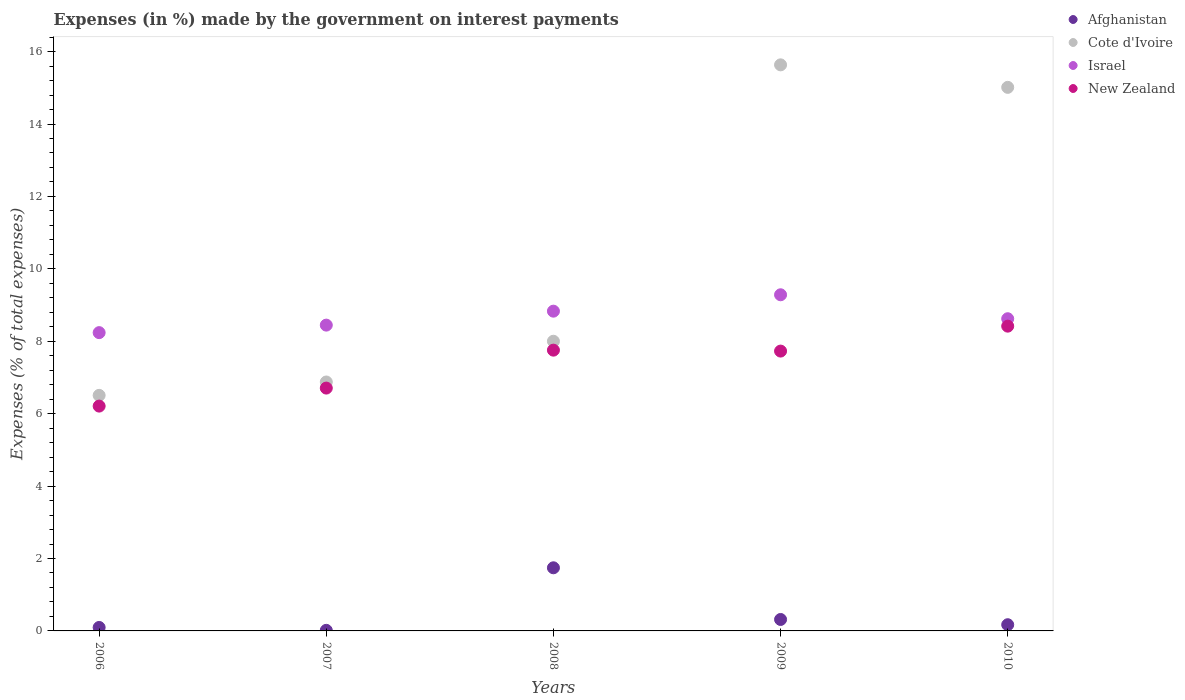What is the percentage of expenses made by the government on interest payments in New Zealand in 2010?
Keep it short and to the point. 8.42. Across all years, what is the maximum percentage of expenses made by the government on interest payments in New Zealand?
Your answer should be compact. 8.42. Across all years, what is the minimum percentage of expenses made by the government on interest payments in Cote d'Ivoire?
Make the answer very short. 6.51. In which year was the percentage of expenses made by the government on interest payments in Israel maximum?
Offer a terse response. 2009. What is the total percentage of expenses made by the government on interest payments in New Zealand in the graph?
Offer a very short reply. 36.82. What is the difference between the percentage of expenses made by the government on interest payments in Cote d'Ivoire in 2007 and that in 2008?
Ensure brevity in your answer.  -1.13. What is the difference between the percentage of expenses made by the government on interest payments in Afghanistan in 2007 and the percentage of expenses made by the government on interest payments in New Zealand in 2010?
Your response must be concise. -8.4. What is the average percentage of expenses made by the government on interest payments in Israel per year?
Make the answer very short. 8.68. In the year 2010, what is the difference between the percentage of expenses made by the government on interest payments in Afghanistan and percentage of expenses made by the government on interest payments in New Zealand?
Provide a short and direct response. -8.25. In how many years, is the percentage of expenses made by the government on interest payments in Israel greater than 14.8 %?
Your answer should be compact. 0. What is the ratio of the percentage of expenses made by the government on interest payments in Cote d'Ivoire in 2007 to that in 2008?
Your answer should be compact. 0.86. Is the difference between the percentage of expenses made by the government on interest payments in Afghanistan in 2008 and 2010 greater than the difference between the percentage of expenses made by the government on interest payments in New Zealand in 2008 and 2010?
Offer a terse response. Yes. What is the difference between the highest and the second highest percentage of expenses made by the government on interest payments in New Zealand?
Offer a very short reply. 0.66. What is the difference between the highest and the lowest percentage of expenses made by the government on interest payments in Afghanistan?
Your answer should be compact. 1.73. Is it the case that in every year, the sum of the percentage of expenses made by the government on interest payments in Cote d'Ivoire and percentage of expenses made by the government on interest payments in New Zealand  is greater than the percentage of expenses made by the government on interest payments in Afghanistan?
Offer a terse response. Yes. How many dotlines are there?
Provide a short and direct response. 4. What is the difference between two consecutive major ticks on the Y-axis?
Provide a short and direct response. 2. Where does the legend appear in the graph?
Your response must be concise. Top right. How many legend labels are there?
Ensure brevity in your answer.  4. How are the legend labels stacked?
Your answer should be compact. Vertical. What is the title of the graph?
Your answer should be compact. Expenses (in %) made by the government on interest payments. Does "Vietnam" appear as one of the legend labels in the graph?
Offer a very short reply. No. What is the label or title of the Y-axis?
Your answer should be very brief. Expenses (% of total expenses). What is the Expenses (% of total expenses) of Afghanistan in 2006?
Provide a short and direct response. 0.1. What is the Expenses (% of total expenses) in Cote d'Ivoire in 2006?
Offer a very short reply. 6.51. What is the Expenses (% of total expenses) of Israel in 2006?
Offer a terse response. 8.24. What is the Expenses (% of total expenses) of New Zealand in 2006?
Offer a terse response. 6.21. What is the Expenses (% of total expenses) in Afghanistan in 2007?
Keep it short and to the point. 0.02. What is the Expenses (% of total expenses) in Cote d'Ivoire in 2007?
Your response must be concise. 6.88. What is the Expenses (% of total expenses) of Israel in 2007?
Your answer should be very brief. 8.45. What is the Expenses (% of total expenses) of New Zealand in 2007?
Offer a terse response. 6.71. What is the Expenses (% of total expenses) of Afghanistan in 2008?
Offer a very short reply. 1.74. What is the Expenses (% of total expenses) of Cote d'Ivoire in 2008?
Make the answer very short. 8. What is the Expenses (% of total expenses) in Israel in 2008?
Your answer should be compact. 8.83. What is the Expenses (% of total expenses) in New Zealand in 2008?
Offer a very short reply. 7.75. What is the Expenses (% of total expenses) in Afghanistan in 2009?
Provide a short and direct response. 0.32. What is the Expenses (% of total expenses) of Cote d'Ivoire in 2009?
Offer a terse response. 15.63. What is the Expenses (% of total expenses) in Israel in 2009?
Make the answer very short. 9.28. What is the Expenses (% of total expenses) in New Zealand in 2009?
Give a very brief answer. 7.73. What is the Expenses (% of total expenses) of Afghanistan in 2010?
Your answer should be very brief. 0.17. What is the Expenses (% of total expenses) of Cote d'Ivoire in 2010?
Offer a very short reply. 15.01. What is the Expenses (% of total expenses) of Israel in 2010?
Provide a short and direct response. 8.62. What is the Expenses (% of total expenses) of New Zealand in 2010?
Your answer should be compact. 8.42. Across all years, what is the maximum Expenses (% of total expenses) of Afghanistan?
Your answer should be very brief. 1.74. Across all years, what is the maximum Expenses (% of total expenses) of Cote d'Ivoire?
Your response must be concise. 15.63. Across all years, what is the maximum Expenses (% of total expenses) of Israel?
Offer a terse response. 9.28. Across all years, what is the maximum Expenses (% of total expenses) in New Zealand?
Offer a terse response. 8.42. Across all years, what is the minimum Expenses (% of total expenses) of Afghanistan?
Keep it short and to the point. 0.02. Across all years, what is the minimum Expenses (% of total expenses) in Cote d'Ivoire?
Your answer should be compact. 6.51. Across all years, what is the minimum Expenses (% of total expenses) in Israel?
Give a very brief answer. 8.24. Across all years, what is the minimum Expenses (% of total expenses) of New Zealand?
Your answer should be very brief. 6.21. What is the total Expenses (% of total expenses) in Afghanistan in the graph?
Make the answer very short. 2.34. What is the total Expenses (% of total expenses) in Cote d'Ivoire in the graph?
Give a very brief answer. 52.03. What is the total Expenses (% of total expenses) in Israel in the graph?
Keep it short and to the point. 43.42. What is the total Expenses (% of total expenses) in New Zealand in the graph?
Your answer should be compact. 36.82. What is the difference between the Expenses (% of total expenses) in Afghanistan in 2006 and that in 2007?
Give a very brief answer. 0.08. What is the difference between the Expenses (% of total expenses) of Cote d'Ivoire in 2006 and that in 2007?
Offer a very short reply. -0.37. What is the difference between the Expenses (% of total expenses) of Israel in 2006 and that in 2007?
Your response must be concise. -0.21. What is the difference between the Expenses (% of total expenses) of New Zealand in 2006 and that in 2007?
Provide a short and direct response. -0.5. What is the difference between the Expenses (% of total expenses) of Afghanistan in 2006 and that in 2008?
Your answer should be very brief. -1.65. What is the difference between the Expenses (% of total expenses) in Cote d'Ivoire in 2006 and that in 2008?
Provide a short and direct response. -1.49. What is the difference between the Expenses (% of total expenses) of Israel in 2006 and that in 2008?
Your answer should be compact. -0.59. What is the difference between the Expenses (% of total expenses) in New Zealand in 2006 and that in 2008?
Provide a short and direct response. -1.55. What is the difference between the Expenses (% of total expenses) of Afghanistan in 2006 and that in 2009?
Offer a terse response. -0.22. What is the difference between the Expenses (% of total expenses) of Cote d'Ivoire in 2006 and that in 2009?
Your answer should be compact. -9.13. What is the difference between the Expenses (% of total expenses) of Israel in 2006 and that in 2009?
Your answer should be compact. -1.05. What is the difference between the Expenses (% of total expenses) of New Zealand in 2006 and that in 2009?
Offer a terse response. -1.52. What is the difference between the Expenses (% of total expenses) in Afghanistan in 2006 and that in 2010?
Ensure brevity in your answer.  -0.08. What is the difference between the Expenses (% of total expenses) in Cote d'Ivoire in 2006 and that in 2010?
Provide a short and direct response. -8.51. What is the difference between the Expenses (% of total expenses) of Israel in 2006 and that in 2010?
Your answer should be very brief. -0.38. What is the difference between the Expenses (% of total expenses) in New Zealand in 2006 and that in 2010?
Make the answer very short. -2.21. What is the difference between the Expenses (% of total expenses) in Afghanistan in 2007 and that in 2008?
Offer a terse response. -1.73. What is the difference between the Expenses (% of total expenses) of Cote d'Ivoire in 2007 and that in 2008?
Ensure brevity in your answer.  -1.13. What is the difference between the Expenses (% of total expenses) in Israel in 2007 and that in 2008?
Provide a short and direct response. -0.39. What is the difference between the Expenses (% of total expenses) in New Zealand in 2007 and that in 2008?
Offer a very short reply. -1.05. What is the difference between the Expenses (% of total expenses) of Afghanistan in 2007 and that in 2009?
Make the answer very short. -0.3. What is the difference between the Expenses (% of total expenses) in Cote d'Ivoire in 2007 and that in 2009?
Offer a terse response. -8.76. What is the difference between the Expenses (% of total expenses) of Israel in 2007 and that in 2009?
Make the answer very short. -0.84. What is the difference between the Expenses (% of total expenses) in New Zealand in 2007 and that in 2009?
Your answer should be very brief. -1.02. What is the difference between the Expenses (% of total expenses) of Afghanistan in 2007 and that in 2010?
Make the answer very short. -0.16. What is the difference between the Expenses (% of total expenses) in Cote d'Ivoire in 2007 and that in 2010?
Ensure brevity in your answer.  -8.14. What is the difference between the Expenses (% of total expenses) in Israel in 2007 and that in 2010?
Your answer should be compact. -0.18. What is the difference between the Expenses (% of total expenses) in New Zealand in 2007 and that in 2010?
Provide a succinct answer. -1.71. What is the difference between the Expenses (% of total expenses) of Afghanistan in 2008 and that in 2009?
Your answer should be compact. 1.43. What is the difference between the Expenses (% of total expenses) in Cote d'Ivoire in 2008 and that in 2009?
Offer a terse response. -7.63. What is the difference between the Expenses (% of total expenses) of Israel in 2008 and that in 2009?
Keep it short and to the point. -0.45. What is the difference between the Expenses (% of total expenses) of New Zealand in 2008 and that in 2009?
Offer a terse response. 0.03. What is the difference between the Expenses (% of total expenses) in Afghanistan in 2008 and that in 2010?
Provide a short and direct response. 1.57. What is the difference between the Expenses (% of total expenses) of Cote d'Ivoire in 2008 and that in 2010?
Offer a terse response. -7.01. What is the difference between the Expenses (% of total expenses) in Israel in 2008 and that in 2010?
Provide a short and direct response. 0.21. What is the difference between the Expenses (% of total expenses) in New Zealand in 2008 and that in 2010?
Your answer should be compact. -0.66. What is the difference between the Expenses (% of total expenses) of Afghanistan in 2009 and that in 2010?
Provide a short and direct response. 0.14. What is the difference between the Expenses (% of total expenses) in Cote d'Ivoire in 2009 and that in 2010?
Your answer should be very brief. 0.62. What is the difference between the Expenses (% of total expenses) of Israel in 2009 and that in 2010?
Provide a short and direct response. 0.66. What is the difference between the Expenses (% of total expenses) of New Zealand in 2009 and that in 2010?
Offer a very short reply. -0.69. What is the difference between the Expenses (% of total expenses) in Afghanistan in 2006 and the Expenses (% of total expenses) in Cote d'Ivoire in 2007?
Offer a very short reply. -6.78. What is the difference between the Expenses (% of total expenses) in Afghanistan in 2006 and the Expenses (% of total expenses) in Israel in 2007?
Make the answer very short. -8.35. What is the difference between the Expenses (% of total expenses) in Afghanistan in 2006 and the Expenses (% of total expenses) in New Zealand in 2007?
Provide a succinct answer. -6.61. What is the difference between the Expenses (% of total expenses) in Cote d'Ivoire in 2006 and the Expenses (% of total expenses) in Israel in 2007?
Offer a very short reply. -1.94. What is the difference between the Expenses (% of total expenses) of Cote d'Ivoire in 2006 and the Expenses (% of total expenses) of New Zealand in 2007?
Provide a succinct answer. -0.2. What is the difference between the Expenses (% of total expenses) of Israel in 2006 and the Expenses (% of total expenses) of New Zealand in 2007?
Offer a terse response. 1.53. What is the difference between the Expenses (% of total expenses) in Afghanistan in 2006 and the Expenses (% of total expenses) in Cote d'Ivoire in 2008?
Your response must be concise. -7.9. What is the difference between the Expenses (% of total expenses) in Afghanistan in 2006 and the Expenses (% of total expenses) in Israel in 2008?
Your response must be concise. -8.74. What is the difference between the Expenses (% of total expenses) in Afghanistan in 2006 and the Expenses (% of total expenses) in New Zealand in 2008?
Ensure brevity in your answer.  -7.66. What is the difference between the Expenses (% of total expenses) of Cote d'Ivoire in 2006 and the Expenses (% of total expenses) of Israel in 2008?
Your response must be concise. -2.33. What is the difference between the Expenses (% of total expenses) in Cote d'Ivoire in 2006 and the Expenses (% of total expenses) in New Zealand in 2008?
Give a very brief answer. -1.25. What is the difference between the Expenses (% of total expenses) of Israel in 2006 and the Expenses (% of total expenses) of New Zealand in 2008?
Provide a succinct answer. 0.48. What is the difference between the Expenses (% of total expenses) of Afghanistan in 2006 and the Expenses (% of total expenses) of Cote d'Ivoire in 2009?
Provide a succinct answer. -15.54. What is the difference between the Expenses (% of total expenses) of Afghanistan in 2006 and the Expenses (% of total expenses) of Israel in 2009?
Your response must be concise. -9.19. What is the difference between the Expenses (% of total expenses) of Afghanistan in 2006 and the Expenses (% of total expenses) of New Zealand in 2009?
Provide a succinct answer. -7.63. What is the difference between the Expenses (% of total expenses) of Cote d'Ivoire in 2006 and the Expenses (% of total expenses) of Israel in 2009?
Provide a succinct answer. -2.78. What is the difference between the Expenses (% of total expenses) of Cote d'Ivoire in 2006 and the Expenses (% of total expenses) of New Zealand in 2009?
Provide a short and direct response. -1.22. What is the difference between the Expenses (% of total expenses) in Israel in 2006 and the Expenses (% of total expenses) in New Zealand in 2009?
Offer a very short reply. 0.51. What is the difference between the Expenses (% of total expenses) of Afghanistan in 2006 and the Expenses (% of total expenses) of Cote d'Ivoire in 2010?
Offer a very short reply. -14.92. What is the difference between the Expenses (% of total expenses) of Afghanistan in 2006 and the Expenses (% of total expenses) of Israel in 2010?
Make the answer very short. -8.53. What is the difference between the Expenses (% of total expenses) in Afghanistan in 2006 and the Expenses (% of total expenses) in New Zealand in 2010?
Make the answer very short. -8.32. What is the difference between the Expenses (% of total expenses) of Cote d'Ivoire in 2006 and the Expenses (% of total expenses) of Israel in 2010?
Ensure brevity in your answer.  -2.12. What is the difference between the Expenses (% of total expenses) in Cote d'Ivoire in 2006 and the Expenses (% of total expenses) in New Zealand in 2010?
Make the answer very short. -1.91. What is the difference between the Expenses (% of total expenses) of Israel in 2006 and the Expenses (% of total expenses) of New Zealand in 2010?
Your response must be concise. -0.18. What is the difference between the Expenses (% of total expenses) in Afghanistan in 2007 and the Expenses (% of total expenses) in Cote d'Ivoire in 2008?
Your answer should be very brief. -7.98. What is the difference between the Expenses (% of total expenses) of Afghanistan in 2007 and the Expenses (% of total expenses) of Israel in 2008?
Provide a succinct answer. -8.82. What is the difference between the Expenses (% of total expenses) in Afghanistan in 2007 and the Expenses (% of total expenses) in New Zealand in 2008?
Provide a succinct answer. -7.74. What is the difference between the Expenses (% of total expenses) of Cote d'Ivoire in 2007 and the Expenses (% of total expenses) of Israel in 2008?
Provide a short and direct response. -1.96. What is the difference between the Expenses (% of total expenses) of Cote d'Ivoire in 2007 and the Expenses (% of total expenses) of New Zealand in 2008?
Provide a succinct answer. -0.88. What is the difference between the Expenses (% of total expenses) of Israel in 2007 and the Expenses (% of total expenses) of New Zealand in 2008?
Provide a short and direct response. 0.69. What is the difference between the Expenses (% of total expenses) in Afghanistan in 2007 and the Expenses (% of total expenses) in Cote d'Ivoire in 2009?
Offer a terse response. -15.62. What is the difference between the Expenses (% of total expenses) of Afghanistan in 2007 and the Expenses (% of total expenses) of Israel in 2009?
Keep it short and to the point. -9.27. What is the difference between the Expenses (% of total expenses) in Afghanistan in 2007 and the Expenses (% of total expenses) in New Zealand in 2009?
Ensure brevity in your answer.  -7.71. What is the difference between the Expenses (% of total expenses) of Cote d'Ivoire in 2007 and the Expenses (% of total expenses) of Israel in 2009?
Offer a very short reply. -2.41. What is the difference between the Expenses (% of total expenses) in Cote d'Ivoire in 2007 and the Expenses (% of total expenses) in New Zealand in 2009?
Offer a very short reply. -0.85. What is the difference between the Expenses (% of total expenses) in Israel in 2007 and the Expenses (% of total expenses) in New Zealand in 2009?
Your response must be concise. 0.72. What is the difference between the Expenses (% of total expenses) in Afghanistan in 2007 and the Expenses (% of total expenses) in Cote d'Ivoire in 2010?
Keep it short and to the point. -15. What is the difference between the Expenses (% of total expenses) in Afghanistan in 2007 and the Expenses (% of total expenses) in Israel in 2010?
Your answer should be very brief. -8.61. What is the difference between the Expenses (% of total expenses) of Afghanistan in 2007 and the Expenses (% of total expenses) of New Zealand in 2010?
Your response must be concise. -8.4. What is the difference between the Expenses (% of total expenses) in Cote d'Ivoire in 2007 and the Expenses (% of total expenses) in Israel in 2010?
Your answer should be very brief. -1.75. What is the difference between the Expenses (% of total expenses) in Cote d'Ivoire in 2007 and the Expenses (% of total expenses) in New Zealand in 2010?
Your answer should be very brief. -1.54. What is the difference between the Expenses (% of total expenses) of Israel in 2007 and the Expenses (% of total expenses) of New Zealand in 2010?
Make the answer very short. 0.03. What is the difference between the Expenses (% of total expenses) in Afghanistan in 2008 and the Expenses (% of total expenses) in Cote d'Ivoire in 2009?
Ensure brevity in your answer.  -13.89. What is the difference between the Expenses (% of total expenses) in Afghanistan in 2008 and the Expenses (% of total expenses) in Israel in 2009?
Your answer should be very brief. -7.54. What is the difference between the Expenses (% of total expenses) in Afghanistan in 2008 and the Expenses (% of total expenses) in New Zealand in 2009?
Make the answer very short. -5.99. What is the difference between the Expenses (% of total expenses) in Cote d'Ivoire in 2008 and the Expenses (% of total expenses) in Israel in 2009?
Your answer should be compact. -1.28. What is the difference between the Expenses (% of total expenses) of Cote d'Ivoire in 2008 and the Expenses (% of total expenses) of New Zealand in 2009?
Keep it short and to the point. 0.27. What is the difference between the Expenses (% of total expenses) in Israel in 2008 and the Expenses (% of total expenses) in New Zealand in 2009?
Make the answer very short. 1.1. What is the difference between the Expenses (% of total expenses) of Afghanistan in 2008 and the Expenses (% of total expenses) of Cote d'Ivoire in 2010?
Your response must be concise. -13.27. What is the difference between the Expenses (% of total expenses) in Afghanistan in 2008 and the Expenses (% of total expenses) in Israel in 2010?
Offer a terse response. -6.88. What is the difference between the Expenses (% of total expenses) of Afghanistan in 2008 and the Expenses (% of total expenses) of New Zealand in 2010?
Offer a very short reply. -6.67. What is the difference between the Expenses (% of total expenses) in Cote d'Ivoire in 2008 and the Expenses (% of total expenses) in Israel in 2010?
Keep it short and to the point. -0.62. What is the difference between the Expenses (% of total expenses) of Cote d'Ivoire in 2008 and the Expenses (% of total expenses) of New Zealand in 2010?
Offer a terse response. -0.42. What is the difference between the Expenses (% of total expenses) of Israel in 2008 and the Expenses (% of total expenses) of New Zealand in 2010?
Give a very brief answer. 0.41. What is the difference between the Expenses (% of total expenses) in Afghanistan in 2009 and the Expenses (% of total expenses) in Cote d'Ivoire in 2010?
Ensure brevity in your answer.  -14.7. What is the difference between the Expenses (% of total expenses) of Afghanistan in 2009 and the Expenses (% of total expenses) of Israel in 2010?
Provide a short and direct response. -8.31. What is the difference between the Expenses (% of total expenses) of Afghanistan in 2009 and the Expenses (% of total expenses) of New Zealand in 2010?
Your answer should be very brief. -8.1. What is the difference between the Expenses (% of total expenses) of Cote d'Ivoire in 2009 and the Expenses (% of total expenses) of Israel in 2010?
Offer a very short reply. 7.01. What is the difference between the Expenses (% of total expenses) of Cote d'Ivoire in 2009 and the Expenses (% of total expenses) of New Zealand in 2010?
Keep it short and to the point. 7.22. What is the difference between the Expenses (% of total expenses) in Israel in 2009 and the Expenses (% of total expenses) in New Zealand in 2010?
Your answer should be very brief. 0.87. What is the average Expenses (% of total expenses) in Afghanistan per year?
Offer a very short reply. 0.47. What is the average Expenses (% of total expenses) of Cote d'Ivoire per year?
Offer a terse response. 10.41. What is the average Expenses (% of total expenses) in Israel per year?
Provide a succinct answer. 8.68. What is the average Expenses (% of total expenses) of New Zealand per year?
Provide a succinct answer. 7.36. In the year 2006, what is the difference between the Expenses (% of total expenses) of Afghanistan and Expenses (% of total expenses) of Cote d'Ivoire?
Offer a terse response. -6.41. In the year 2006, what is the difference between the Expenses (% of total expenses) in Afghanistan and Expenses (% of total expenses) in Israel?
Provide a short and direct response. -8.14. In the year 2006, what is the difference between the Expenses (% of total expenses) of Afghanistan and Expenses (% of total expenses) of New Zealand?
Provide a short and direct response. -6.11. In the year 2006, what is the difference between the Expenses (% of total expenses) of Cote d'Ivoire and Expenses (% of total expenses) of Israel?
Keep it short and to the point. -1.73. In the year 2006, what is the difference between the Expenses (% of total expenses) in Cote d'Ivoire and Expenses (% of total expenses) in New Zealand?
Make the answer very short. 0.3. In the year 2006, what is the difference between the Expenses (% of total expenses) in Israel and Expenses (% of total expenses) in New Zealand?
Your answer should be compact. 2.03. In the year 2007, what is the difference between the Expenses (% of total expenses) of Afghanistan and Expenses (% of total expenses) of Cote d'Ivoire?
Your answer should be compact. -6.86. In the year 2007, what is the difference between the Expenses (% of total expenses) in Afghanistan and Expenses (% of total expenses) in Israel?
Give a very brief answer. -8.43. In the year 2007, what is the difference between the Expenses (% of total expenses) in Afghanistan and Expenses (% of total expenses) in New Zealand?
Provide a succinct answer. -6.69. In the year 2007, what is the difference between the Expenses (% of total expenses) in Cote d'Ivoire and Expenses (% of total expenses) in Israel?
Give a very brief answer. -1.57. In the year 2007, what is the difference between the Expenses (% of total expenses) in Cote d'Ivoire and Expenses (% of total expenses) in New Zealand?
Provide a short and direct response. 0.17. In the year 2007, what is the difference between the Expenses (% of total expenses) of Israel and Expenses (% of total expenses) of New Zealand?
Offer a very short reply. 1.74. In the year 2008, what is the difference between the Expenses (% of total expenses) of Afghanistan and Expenses (% of total expenses) of Cote d'Ivoire?
Give a very brief answer. -6.26. In the year 2008, what is the difference between the Expenses (% of total expenses) of Afghanistan and Expenses (% of total expenses) of Israel?
Provide a succinct answer. -7.09. In the year 2008, what is the difference between the Expenses (% of total expenses) of Afghanistan and Expenses (% of total expenses) of New Zealand?
Keep it short and to the point. -6.01. In the year 2008, what is the difference between the Expenses (% of total expenses) of Cote d'Ivoire and Expenses (% of total expenses) of Israel?
Your answer should be very brief. -0.83. In the year 2008, what is the difference between the Expenses (% of total expenses) of Cote d'Ivoire and Expenses (% of total expenses) of New Zealand?
Ensure brevity in your answer.  0.25. In the year 2008, what is the difference between the Expenses (% of total expenses) in Israel and Expenses (% of total expenses) in New Zealand?
Offer a very short reply. 1.08. In the year 2009, what is the difference between the Expenses (% of total expenses) of Afghanistan and Expenses (% of total expenses) of Cote d'Ivoire?
Your response must be concise. -15.32. In the year 2009, what is the difference between the Expenses (% of total expenses) in Afghanistan and Expenses (% of total expenses) in Israel?
Provide a short and direct response. -8.97. In the year 2009, what is the difference between the Expenses (% of total expenses) in Afghanistan and Expenses (% of total expenses) in New Zealand?
Your answer should be very brief. -7.41. In the year 2009, what is the difference between the Expenses (% of total expenses) of Cote d'Ivoire and Expenses (% of total expenses) of Israel?
Offer a terse response. 6.35. In the year 2009, what is the difference between the Expenses (% of total expenses) in Cote d'Ivoire and Expenses (% of total expenses) in New Zealand?
Offer a very short reply. 7.91. In the year 2009, what is the difference between the Expenses (% of total expenses) of Israel and Expenses (% of total expenses) of New Zealand?
Give a very brief answer. 1.56. In the year 2010, what is the difference between the Expenses (% of total expenses) of Afghanistan and Expenses (% of total expenses) of Cote d'Ivoire?
Provide a short and direct response. -14.84. In the year 2010, what is the difference between the Expenses (% of total expenses) in Afghanistan and Expenses (% of total expenses) in Israel?
Give a very brief answer. -8.45. In the year 2010, what is the difference between the Expenses (% of total expenses) in Afghanistan and Expenses (% of total expenses) in New Zealand?
Offer a terse response. -8.25. In the year 2010, what is the difference between the Expenses (% of total expenses) of Cote d'Ivoire and Expenses (% of total expenses) of Israel?
Give a very brief answer. 6.39. In the year 2010, what is the difference between the Expenses (% of total expenses) of Cote d'Ivoire and Expenses (% of total expenses) of New Zealand?
Give a very brief answer. 6.6. In the year 2010, what is the difference between the Expenses (% of total expenses) of Israel and Expenses (% of total expenses) of New Zealand?
Keep it short and to the point. 0.21. What is the ratio of the Expenses (% of total expenses) of Afghanistan in 2006 to that in 2007?
Keep it short and to the point. 5.95. What is the ratio of the Expenses (% of total expenses) of Cote d'Ivoire in 2006 to that in 2007?
Provide a succinct answer. 0.95. What is the ratio of the Expenses (% of total expenses) of Israel in 2006 to that in 2007?
Ensure brevity in your answer.  0.98. What is the ratio of the Expenses (% of total expenses) in New Zealand in 2006 to that in 2007?
Provide a succinct answer. 0.93. What is the ratio of the Expenses (% of total expenses) of Afghanistan in 2006 to that in 2008?
Offer a terse response. 0.05. What is the ratio of the Expenses (% of total expenses) of Cote d'Ivoire in 2006 to that in 2008?
Make the answer very short. 0.81. What is the ratio of the Expenses (% of total expenses) in Israel in 2006 to that in 2008?
Keep it short and to the point. 0.93. What is the ratio of the Expenses (% of total expenses) in New Zealand in 2006 to that in 2008?
Give a very brief answer. 0.8. What is the ratio of the Expenses (% of total expenses) of Afghanistan in 2006 to that in 2009?
Offer a very short reply. 0.3. What is the ratio of the Expenses (% of total expenses) of Cote d'Ivoire in 2006 to that in 2009?
Give a very brief answer. 0.42. What is the ratio of the Expenses (% of total expenses) in Israel in 2006 to that in 2009?
Your response must be concise. 0.89. What is the ratio of the Expenses (% of total expenses) in New Zealand in 2006 to that in 2009?
Provide a short and direct response. 0.8. What is the ratio of the Expenses (% of total expenses) of Afghanistan in 2006 to that in 2010?
Give a very brief answer. 0.56. What is the ratio of the Expenses (% of total expenses) in Cote d'Ivoire in 2006 to that in 2010?
Your answer should be very brief. 0.43. What is the ratio of the Expenses (% of total expenses) in Israel in 2006 to that in 2010?
Provide a short and direct response. 0.96. What is the ratio of the Expenses (% of total expenses) in New Zealand in 2006 to that in 2010?
Make the answer very short. 0.74. What is the ratio of the Expenses (% of total expenses) in Afghanistan in 2007 to that in 2008?
Give a very brief answer. 0.01. What is the ratio of the Expenses (% of total expenses) of Cote d'Ivoire in 2007 to that in 2008?
Your answer should be compact. 0.86. What is the ratio of the Expenses (% of total expenses) of Israel in 2007 to that in 2008?
Offer a terse response. 0.96. What is the ratio of the Expenses (% of total expenses) in New Zealand in 2007 to that in 2008?
Your answer should be very brief. 0.86. What is the ratio of the Expenses (% of total expenses) in Afghanistan in 2007 to that in 2009?
Offer a very short reply. 0.05. What is the ratio of the Expenses (% of total expenses) of Cote d'Ivoire in 2007 to that in 2009?
Your response must be concise. 0.44. What is the ratio of the Expenses (% of total expenses) of Israel in 2007 to that in 2009?
Your response must be concise. 0.91. What is the ratio of the Expenses (% of total expenses) of New Zealand in 2007 to that in 2009?
Make the answer very short. 0.87. What is the ratio of the Expenses (% of total expenses) of Afghanistan in 2007 to that in 2010?
Your answer should be compact. 0.09. What is the ratio of the Expenses (% of total expenses) in Cote d'Ivoire in 2007 to that in 2010?
Offer a terse response. 0.46. What is the ratio of the Expenses (% of total expenses) of Israel in 2007 to that in 2010?
Your answer should be compact. 0.98. What is the ratio of the Expenses (% of total expenses) of New Zealand in 2007 to that in 2010?
Provide a succinct answer. 0.8. What is the ratio of the Expenses (% of total expenses) of Afghanistan in 2008 to that in 2009?
Offer a very short reply. 5.51. What is the ratio of the Expenses (% of total expenses) of Cote d'Ivoire in 2008 to that in 2009?
Offer a very short reply. 0.51. What is the ratio of the Expenses (% of total expenses) of Israel in 2008 to that in 2009?
Give a very brief answer. 0.95. What is the ratio of the Expenses (% of total expenses) of Afghanistan in 2008 to that in 2010?
Ensure brevity in your answer.  10.18. What is the ratio of the Expenses (% of total expenses) of Cote d'Ivoire in 2008 to that in 2010?
Give a very brief answer. 0.53. What is the ratio of the Expenses (% of total expenses) in Israel in 2008 to that in 2010?
Keep it short and to the point. 1.02. What is the ratio of the Expenses (% of total expenses) in New Zealand in 2008 to that in 2010?
Offer a terse response. 0.92. What is the ratio of the Expenses (% of total expenses) of Afghanistan in 2009 to that in 2010?
Your answer should be very brief. 1.85. What is the ratio of the Expenses (% of total expenses) of Cote d'Ivoire in 2009 to that in 2010?
Provide a succinct answer. 1.04. What is the ratio of the Expenses (% of total expenses) in Israel in 2009 to that in 2010?
Your answer should be compact. 1.08. What is the ratio of the Expenses (% of total expenses) in New Zealand in 2009 to that in 2010?
Provide a short and direct response. 0.92. What is the difference between the highest and the second highest Expenses (% of total expenses) of Afghanistan?
Make the answer very short. 1.43. What is the difference between the highest and the second highest Expenses (% of total expenses) of Cote d'Ivoire?
Provide a succinct answer. 0.62. What is the difference between the highest and the second highest Expenses (% of total expenses) in Israel?
Your answer should be very brief. 0.45. What is the difference between the highest and the second highest Expenses (% of total expenses) of New Zealand?
Your response must be concise. 0.66. What is the difference between the highest and the lowest Expenses (% of total expenses) in Afghanistan?
Your answer should be very brief. 1.73. What is the difference between the highest and the lowest Expenses (% of total expenses) in Cote d'Ivoire?
Offer a very short reply. 9.13. What is the difference between the highest and the lowest Expenses (% of total expenses) of Israel?
Ensure brevity in your answer.  1.05. What is the difference between the highest and the lowest Expenses (% of total expenses) in New Zealand?
Ensure brevity in your answer.  2.21. 